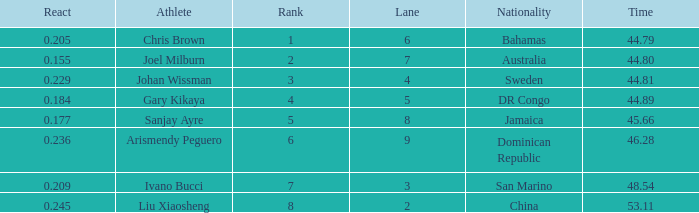What is the total average for Rank entries where the Lane listed is smaller than 4 and the Nationality listed is San Marino? 7.0. 